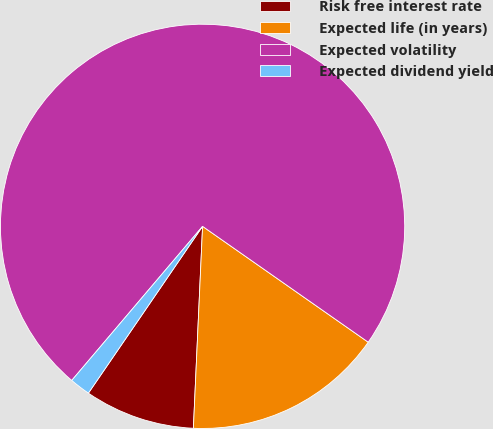<chart> <loc_0><loc_0><loc_500><loc_500><pie_chart><fcel>Risk free interest rate<fcel>Expected life (in years)<fcel>Expected volatility<fcel>Expected dividend yield<nl><fcel>8.83%<fcel>16.01%<fcel>73.51%<fcel>1.65%<nl></chart> 